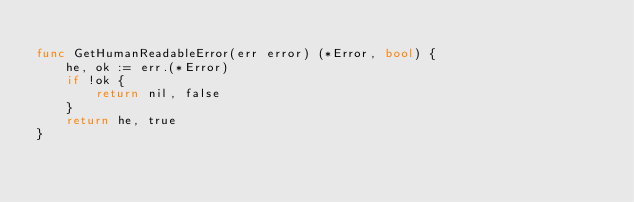Convert code to text. <code><loc_0><loc_0><loc_500><loc_500><_Go_>
func GetHumanReadableError(err error) (*Error, bool) {
	he, ok := err.(*Error)
	if !ok {
		return nil, false
	}
	return he, true
}
</code> 